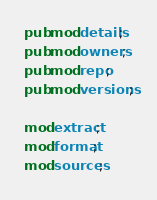Convert code to text. <code><loc_0><loc_0><loc_500><loc_500><_Rust_>pub mod details;
pub mod owners;
pub mod repo;
pub mod versions;

mod extract;
mod format;
mod sources;
</code> 